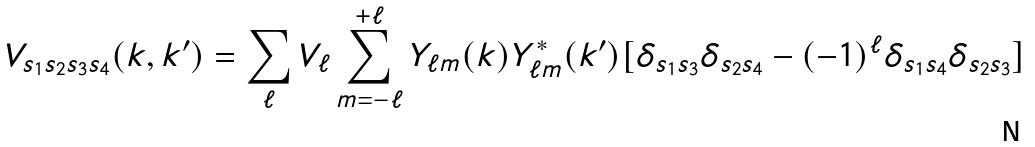Convert formula to latex. <formula><loc_0><loc_0><loc_500><loc_500>V _ { s _ { 1 } s _ { 2 } s _ { 3 } s _ { 4 } } ( { k } , { k } ^ { \prime } ) = \sum _ { \ell } V _ { \ell } \sum ^ { + \ell } _ { m = - \ell } Y _ { \ell m } ( { k } ) Y ^ { * } _ { \ell m } ( { k } ^ { \prime } ) [ \delta _ { s _ { 1 } s _ { 3 } } \delta _ { s _ { 2 } s _ { 4 } } - ( - 1 ) ^ { \ell } \delta _ { s _ { 1 } s _ { 4 } } \delta _ { s _ { 2 } s _ { 3 } } ]</formula> 